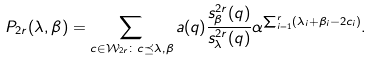Convert formula to latex. <formula><loc_0><loc_0><loc_500><loc_500>P _ { 2 r } ( \lambda , \beta ) = \sum _ { c \in \mathcal { W } _ { 2 r } \colon c \preceq \lambda , \beta } a ( q ) \frac { s ^ { 2 r } _ { \beta } ( q ) } { s ^ { 2 r } _ { \lambda } ( q ) } \alpha ^ { \sum _ { i = 1 } ^ { r } ( \lambda _ { i } + \beta _ { i } - 2 c _ { i } ) } .</formula> 